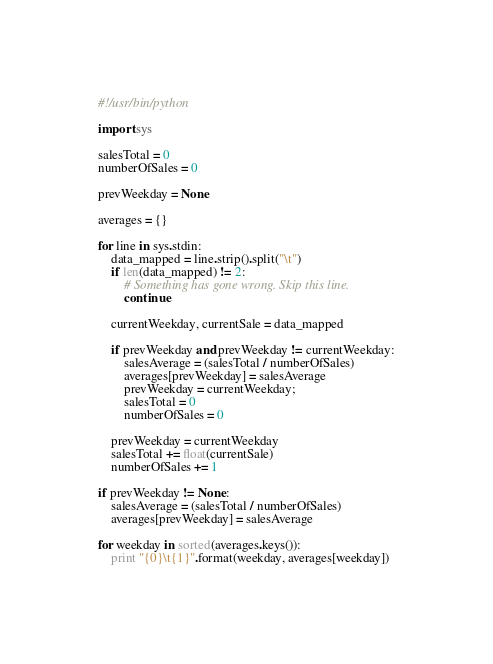<code> <loc_0><loc_0><loc_500><loc_500><_Python_>#!/usr/bin/python

import sys

salesTotal = 0
numberOfSales = 0

prevWeekday = None

averages = {}

for line in sys.stdin:
    data_mapped = line.strip().split("\t")
    if len(data_mapped) != 2:
        # Something has gone wrong. Skip this line.
        continue

    currentWeekday, currentSale = data_mapped

    if prevWeekday and prevWeekday != currentWeekday:
        salesAverage = (salesTotal / numberOfSales)
        averages[prevWeekday] = salesAverage
        prevWeekday = currentWeekday;
        salesTotal = 0
        numberOfSales = 0

    prevWeekday = currentWeekday
    salesTotal += float(currentSale)
    numberOfSales += 1

if prevWeekday != None:
    salesAverage = (salesTotal / numberOfSales)
    averages[prevWeekday] = salesAverage

for weekday in sorted(averages.keys()):
    print "{0}\t{1}".format(weekday, averages[weekday])
</code> 